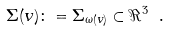<formula> <loc_0><loc_0><loc_500><loc_500>\Sigma ( v ) \colon = \Sigma _ { \omega ( v ) } \subset \Re ^ { 3 } \ .</formula> 